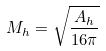Convert formula to latex. <formula><loc_0><loc_0><loc_500><loc_500>M _ { h } = \sqrt { \frac { A _ { h } } { 1 6 \pi } }</formula> 